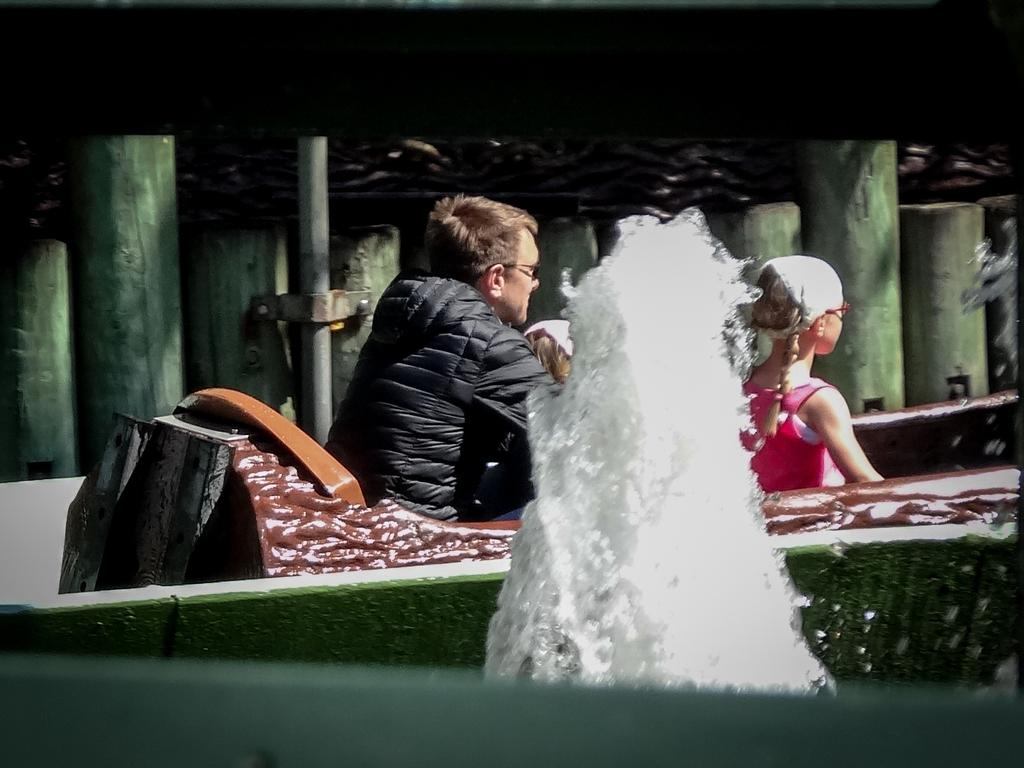How many people are in the image? There are three people in the image: a man and two girls. What are the people in the image doing? They are sitting on an object. Can you describe the object they are sitting on? The object resembles a water fountain. What type of structure can be seen in the image? There are wooden pillars in the image. What else is present in the image? There is a pole in the image. Where is the vase placed in the image? There is no vase present in the image. What type of advice does the grandmother give to the girls in the image? There is no grandmother present in the image, so it is not possible to answer that question. 